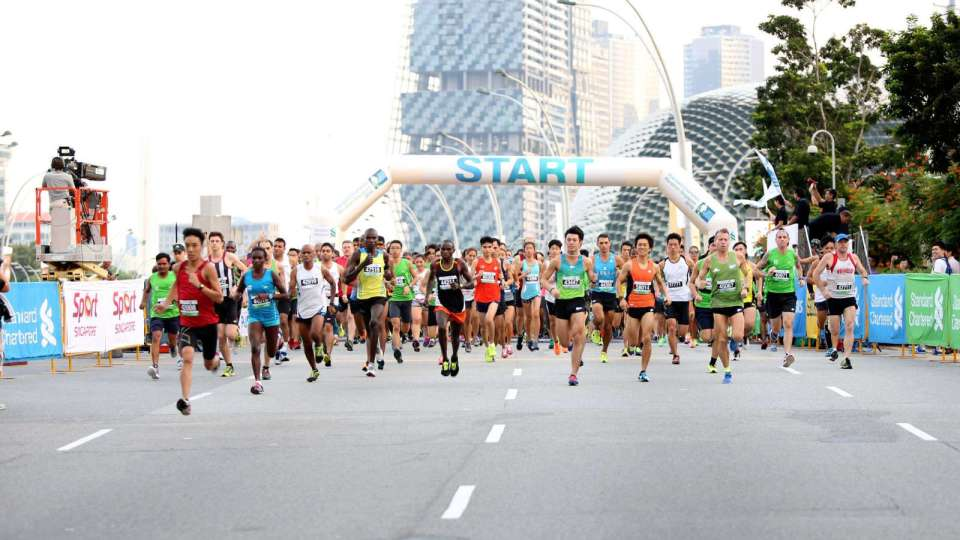Can you describe the mood and composition of the image based on the visible elements? The image depicts a lively and energetic atmosphere with a large group of runners taking off from a 'START' line, indicative of the beginning phase of a race. The variety of vibrant athletic wear and the enthusiastic postures of the runners foster a sense of excitement and anticipation. The architectural backdrop with modern buildings and the substantial crowd contribute to the event's grandeur, making the composition dynamic and engaging. 